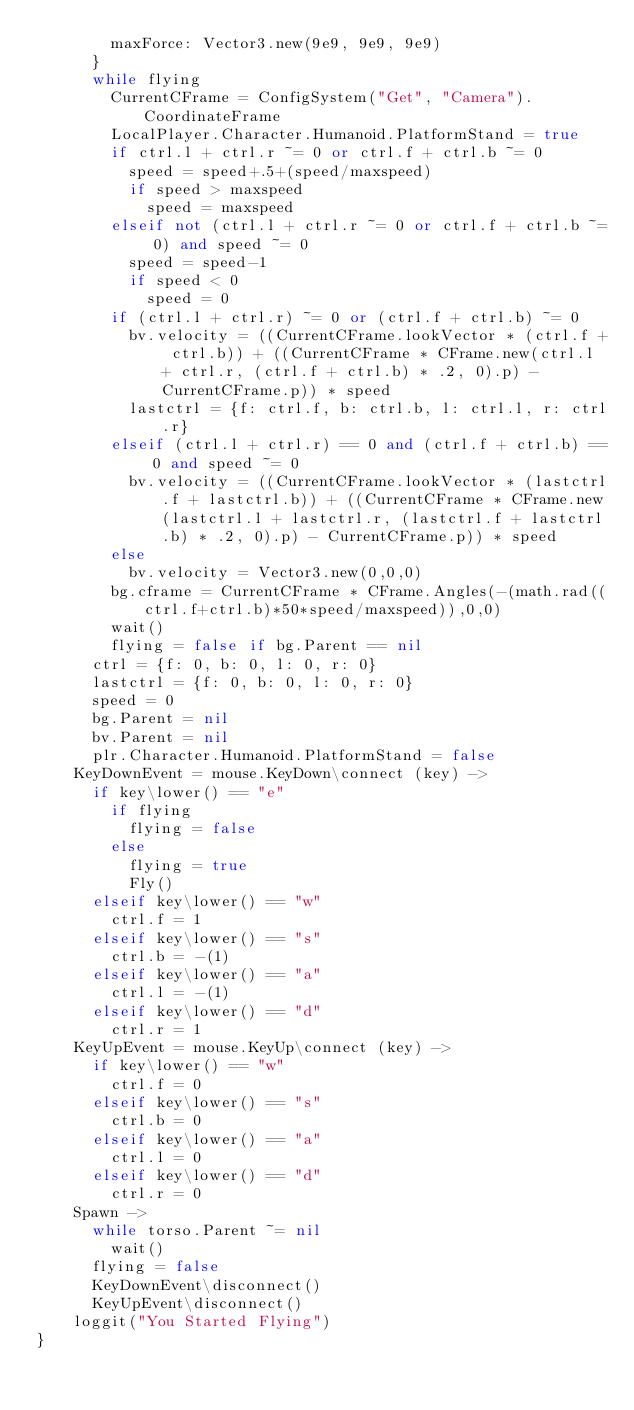<code> <loc_0><loc_0><loc_500><loc_500><_MoonScript_>				maxForce: Vector3.new(9e9, 9e9, 9e9)
			}
			while flying 
				CurrentCFrame = ConfigSystem("Get", "Camera").CoordinateFrame
				LocalPlayer.Character.Humanoid.PlatformStand = true 
				if ctrl.l + ctrl.r ~= 0 or ctrl.f + ctrl.b ~= 0 
					speed = speed+.5+(speed/maxspeed) 
					if speed > maxspeed 
						speed = maxspeed 
				elseif not (ctrl.l + ctrl.r ~= 0 or ctrl.f + ctrl.b ~= 0) and speed ~= 0 
					speed = speed-1 
					if speed < 0 
						speed = 0 
				if (ctrl.l + ctrl.r) ~= 0 or (ctrl.f + ctrl.b) ~= 0 
					bv.velocity = ((CurrentCFrame.lookVector * (ctrl.f + ctrl.b)) + ((CurrentCFrame * CFrame.new(ctrl.l + ctrl.r, (ctrl.f + ctrl.b) * .2, 0).p) - CurrentCFrame.p)) * speed 
					lastctrl = {f: ctrl.f, b: ctrl.b, l: ctrl.l, r: ctrl.r} 
				elseif (ctrl.l + ctrl.r) == 0 and (ctrl.f + ctrl.b) == 0 and speed ~= 0 
					bv.velocity = ((CurrentCFrame.lookVector * (lastctrl.f + lastctrl.b)) + ((CurrentCFrame * CFrame.new(lastctrl.l + lastctrl.r, (lastctrl.f + lastctrl.b) * .2, 0).p) - CurrentCFrame.p)) * speed 
				else 
					bv.velocity = Vector3.new(0,0,0) 
				bg.cframe = CurrentCFrame * CFrame.Angles(-(math.rad((ctrl.f+ctrl.b)*50*speed/maxspeed)),0,0) 
				wait() 
				flying = false if bg.Parent == nil
			ctrl = {f: 0, b: 0, l: 0, r: 0} 
			lastctrl = {f: 0, b: 0, l: 0, r: 0} 
			speed = 0 
			bg.Parent = nil
			bv.Parent = nil
			plr.Character.Humanoid.PlatformStand = false 
		KeyDownEvent = mouse.KeyDown\connect (key) ->
			if key\lower() == "e" 
				if flying
					flying = false 
				else 
					flying = true 
					Fly() 
			elseif key\lower() == "w" 
				ctrl.f = 1 
			elseif key\lower() == "s" 
				ctrl.b = -(1) 
			elseif key\lower() == "a" 
				ctrl.l = -(1) 
			elseif key\lower() == "d" 
				ctrl.r = 1 
		KeyUpEvent = mouse.KeyUp\connect (key) ->
			if key\lower() == "w" 
				ctrl.f = 0 
			elseif key\lower() == "s" 
				ctrl.b = 0 
			elseif key\lower() == "a" 
				ctrl.l = 0 
			elseif key\lower() == "d" 
				ctrl.r = 0 
		Spawn ->
			while torso.Parent ~= nil
				wait() 
			flying = false 
			KeyDownEvent\disconnect()
			KeyUpEvent\disconnect()
		loggit("You Started Flying")
}</code> 